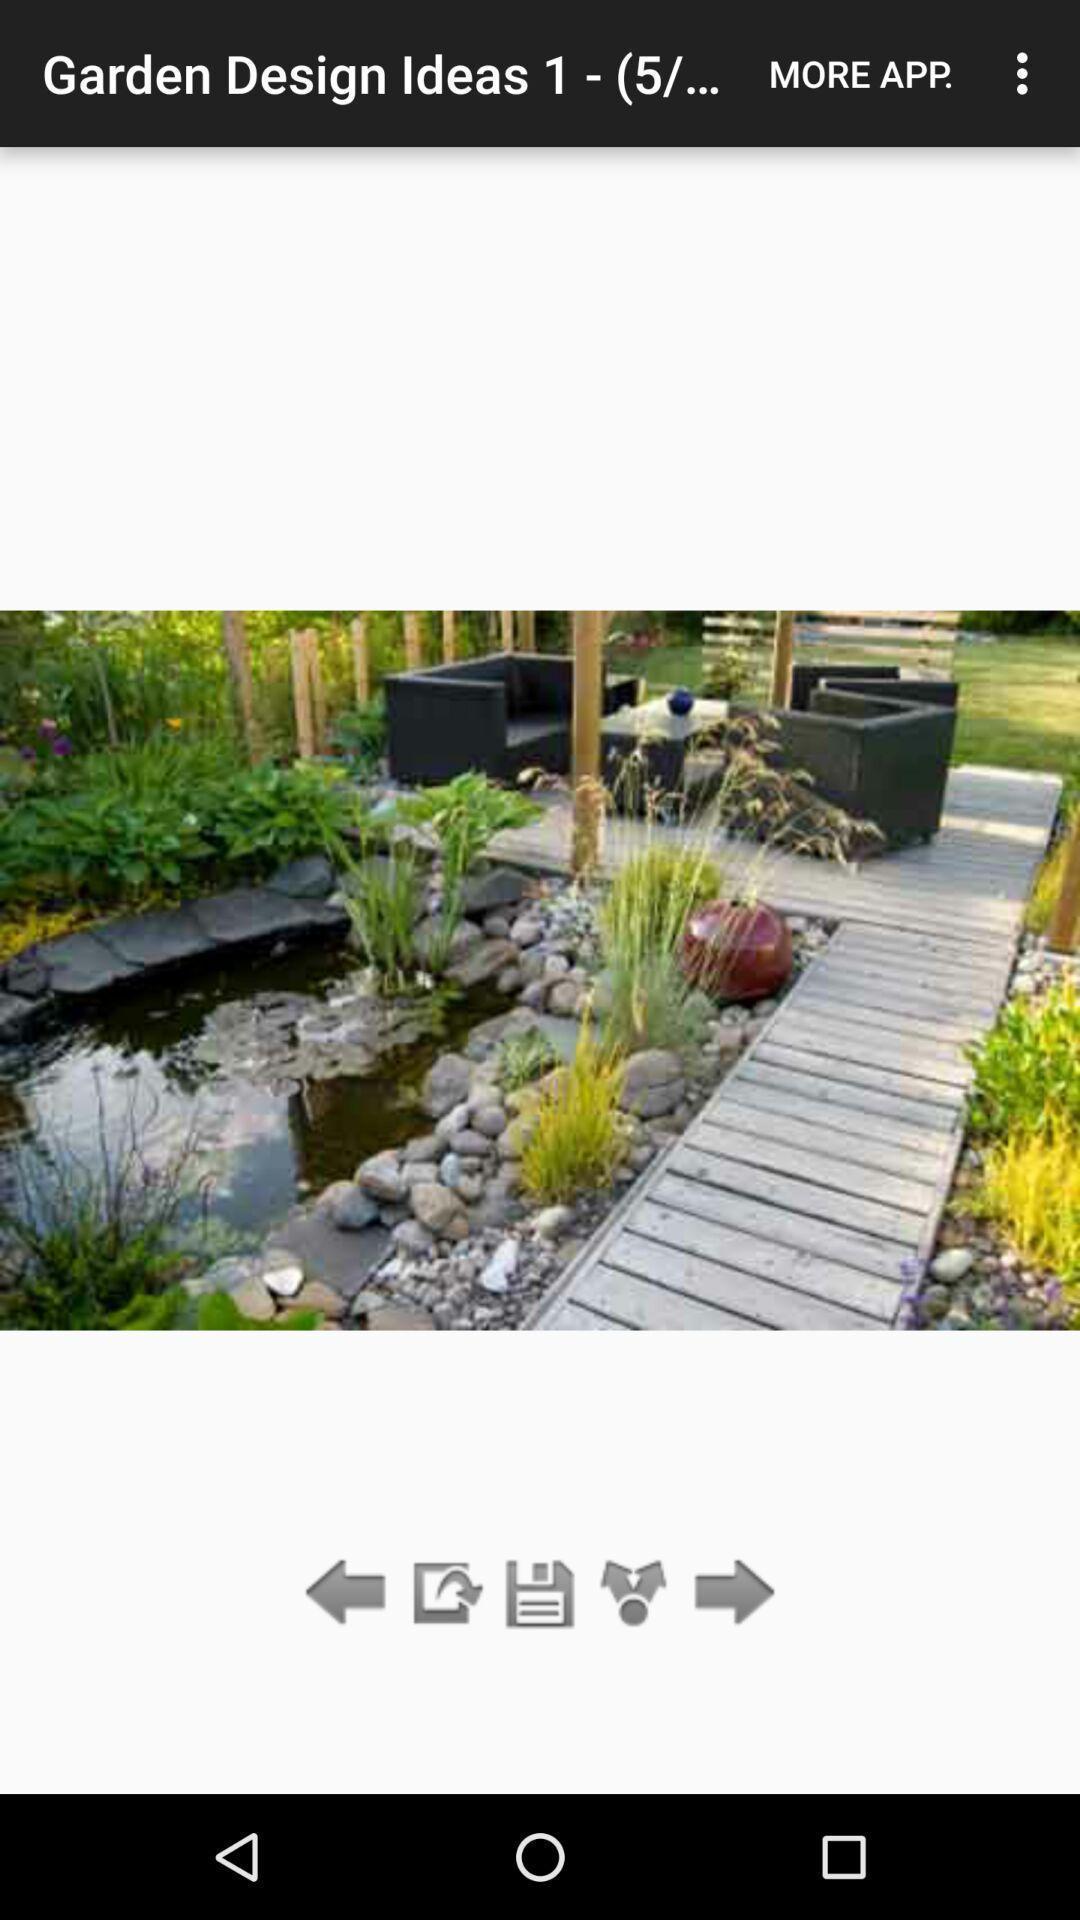Explain the elements present in this screenshot. Page showing garden image. 